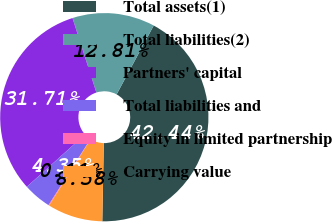Convert chart to OTSL. <chart><loc_0><loc_0><loc_500><loc_500><pie_chart><fcel>Total assets(1)<fcel>Total liabilities(2)<fcel>Partners' capital<fcel>Total liabilities and<fcel>Equity in limited partnership<fcel>Carrying value<nl><fcel>42.44%<fcel>12.81%<fcel>31.71%<fcel>4.35%<fcel>0.11%<fcel>8.58%<nl></chart> 